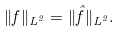Convert formula to latex. <formula><loc_0><loc_0><loc_500><loc_500>\| f \| _ { L ^ { 2 } } = \| \hat { f } \| _ { L ^ { 2 } } .</formula> 